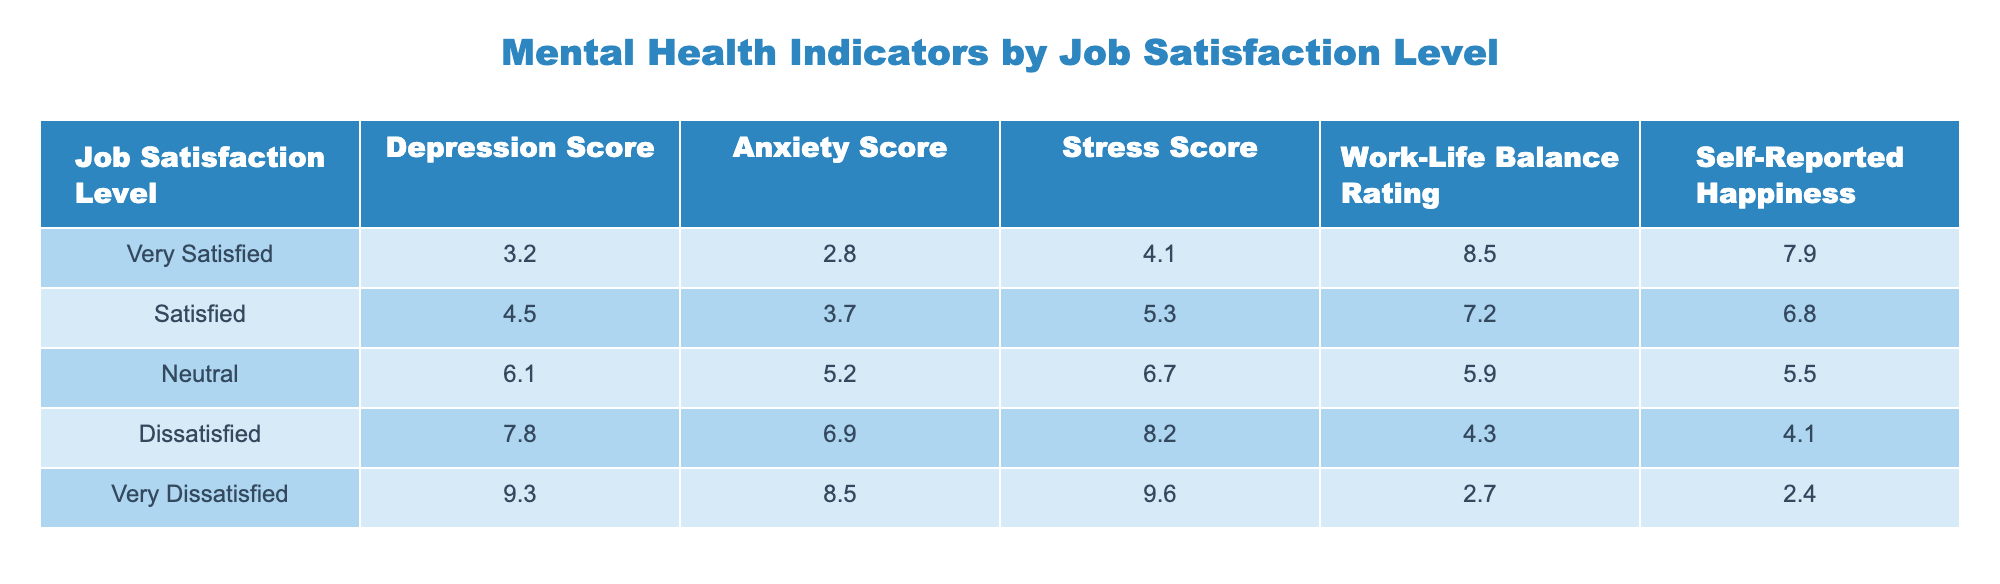What is the Depression Score for employees who are Very Satisfied with their job? The Depression Score is listed under the "Very Satisfied" job satisfaction level in the table, which shows a value of 3.2.
Answer: 3.2 What is the highest Anxiety Score reported among the different job satisfaction levels? The table indicates the Anxiety Scores for each level, with "Very Dissatisfied" showing the highest score of 8.5 compared to others.
Answer: 8.5 What is the average Stress Score for employees who are Neutral and Dissatisfied? To calculate the average Stress Score for these two categories, we sum the values: Neutral (6.7) + Dissatisfied (8.2) = 14.9. Then, we divide by 2 (the number of categories): 14.9 / 2 = 7.45.
Answer: 7.45 Is the Work-Life Balance Rating higher for Satisfied employees than for Neutral employees? The Work-Life Balance Rating for Satisfied employees is 7.2 and for Neutral employees is 5.9. Since 7.2 > 5.9, the statement is true.
Answer: Yes What is the difference in Self-Reported Happiness between the Very Satisfied and Very Dissatisfied employees? The Self-Reported Happiness for Very Satisfied employees is 7.9 and for Very Dissatisfied employees is 2.4. The difference is calculated as 7.9 - 2.4 = 5.5.
Answer: 5.5 What is the Stress Score of employees with the lowest job satisfaction level? The job satisfaction level with the lowest rating is "Very Dissatisfied," which corresponds to a Stress Score of 9.6 as shown in the table.
Answer: 9.6 What level of job satisfaction would likely correlate with the lowest Self-Reported Happiness based on the data? The table shows that "Very Dissatisfied" employees have the lowest Self-Reported Happiness score of 2.4, suggesting a strong negative correlation.
Answer: Very Dissatisfied What is the average Anxiety Score for employees with job satisfaction levels that are either Satisfied or Very Satisfied? The Anxiety Scores for these two groups are Satisfied (3.7) and Very Satisfied (2.8). Summing them gives 3.7 + 2.8 = 6.5, and dividing by 2 provides an average of 3.25.
Answer: 3.25 